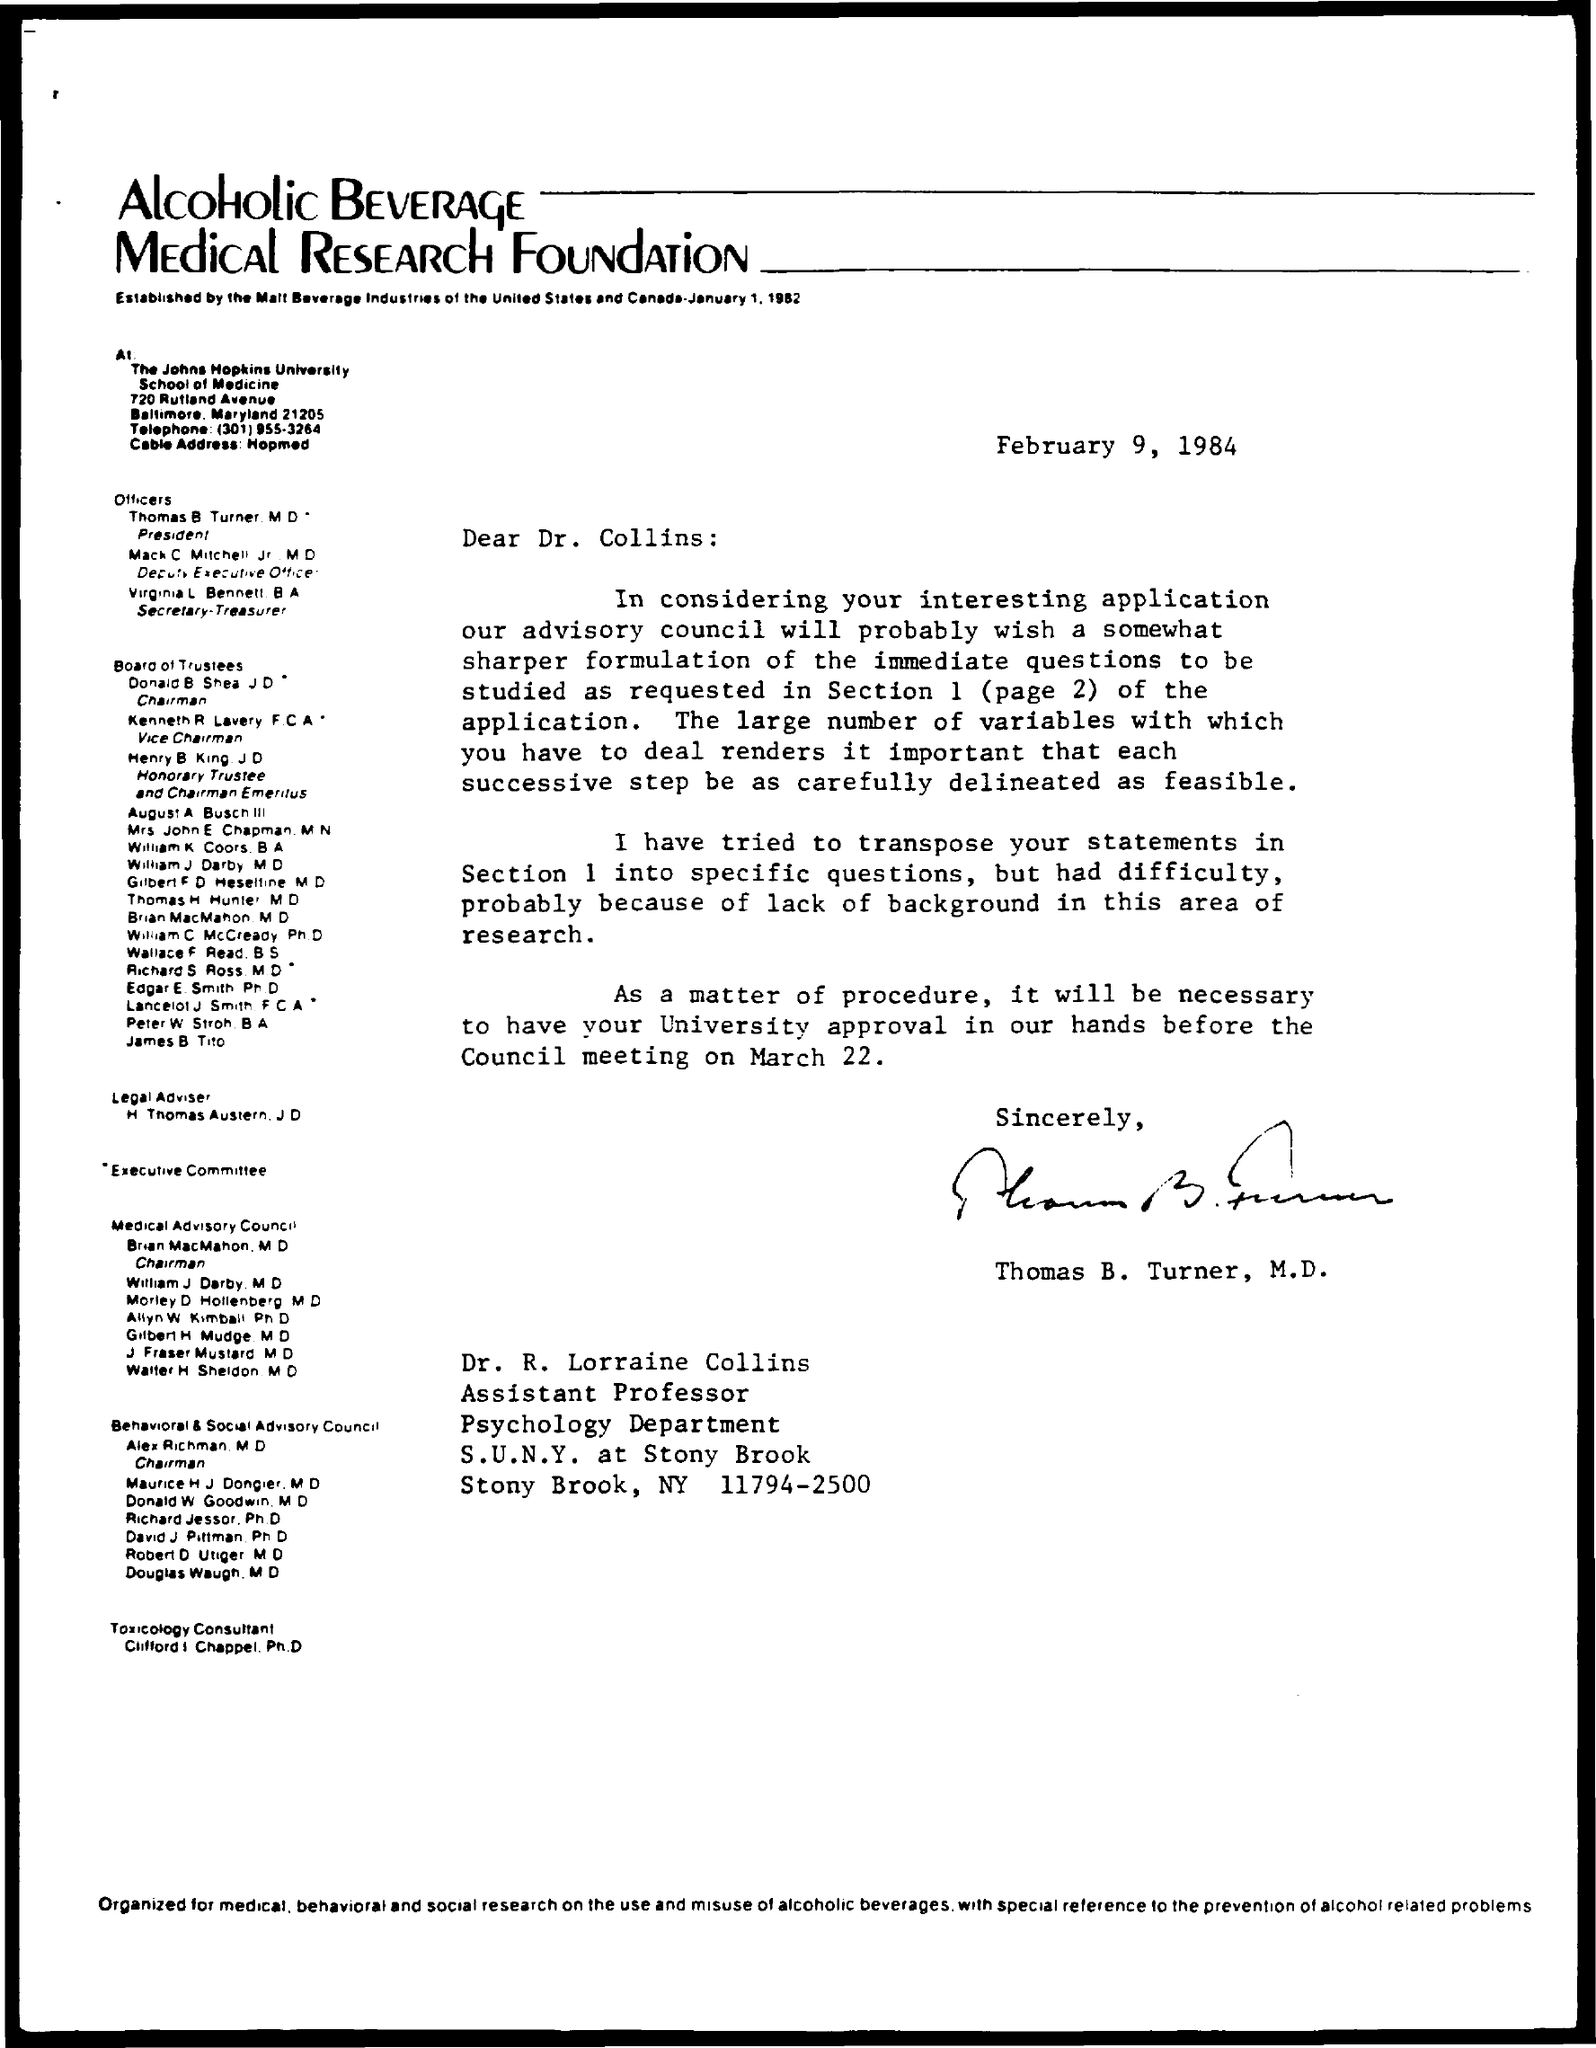Identify some key points in this picture. The letter is from Thomas B. Turner. The letter is addressed to Dr. R. Lorraine Collins. 